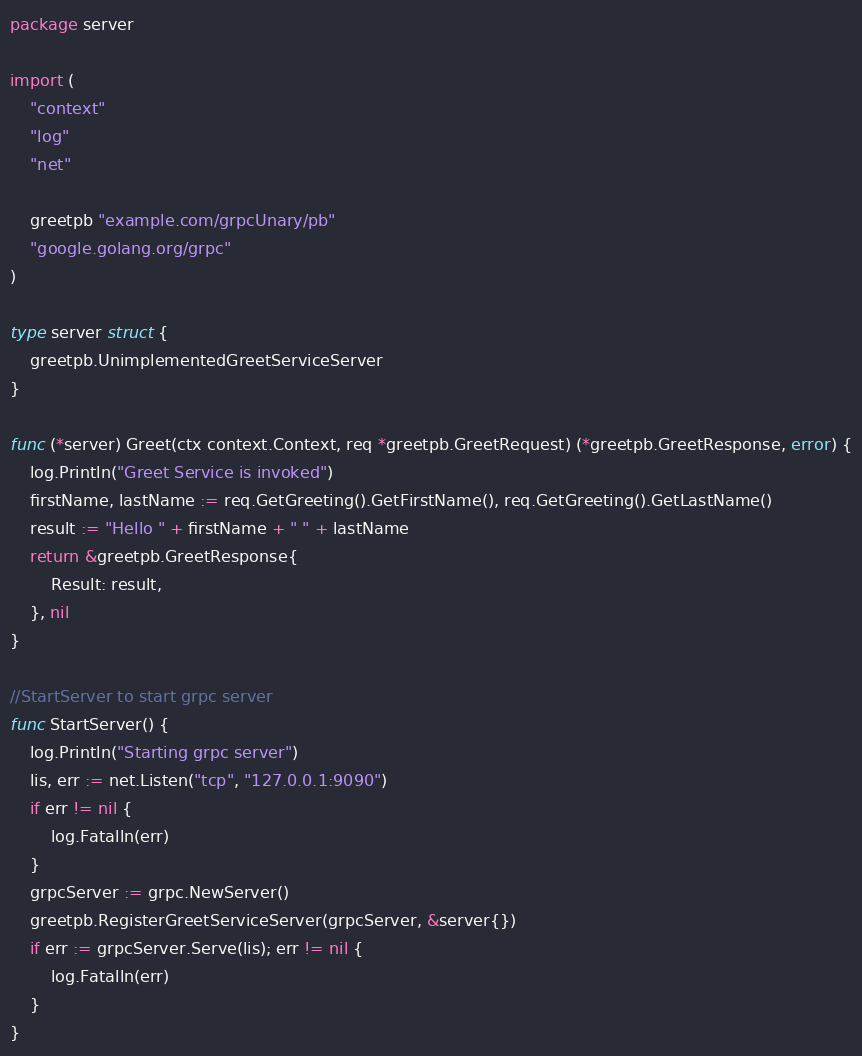Convert code to text. <code><loc_0><loc_0><loc_500><loc_500><_Go_>package server

import (
	"context"
	"log"
	"net"

	greetpb "example.com/grpcUnary/pb"
	"google.golang.org/grpc"
)

type server struct {
	greetpb.UnimplementedGreetServiceServer
}

func (*server) Greet(ctx context.Context, req *greetpb.GreetRequest) (*greetpb.GreetResponse, error) {
	log.Println("Greet Service is invoked")
	firstName, lastName := req.GetGreeting().GetFirstName(), req.GetGreeting().GetLastName()
	result := "Hello " + firstName + " " + lastName
	return &greetpb.GreetResponse{
		Result: result,
	}, nil
}

//StartServer to start grpc server
func StartServer() {
	log.Println("Starting grpc server")
	lis, err := net.Listen("tcp", "127.0.0.1:9090")
	if err != nil {
		log.Fatalln(err)
	}
	grpcServer := grpc.NewServer()
	greetpb.RegisterGreetServiceServer(grpcServer, &server{})
	if err := grpcServer.Serve(lis); err != nil {
		log.Fatalln(err)
	}
}
</code> 